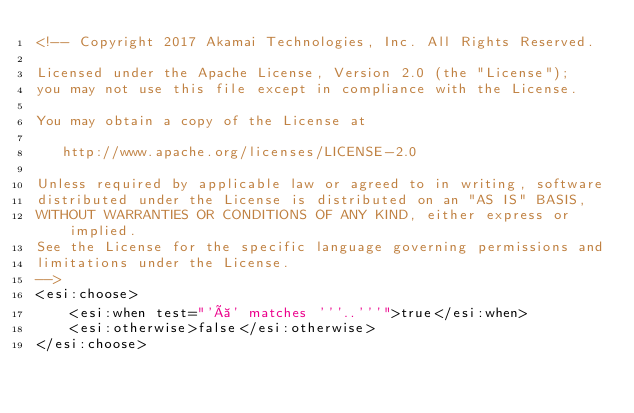<code> <loc_0><loc_0><loc_500><loc_500><_HTML_><!-- Copyright 2017 Akamai Technologies, Inc. All Rights Reserved.

Licensed under the Apache License, Version 2.0 (the "License");
you may not use this file except in compliance with the License.

You may obtain a copy of the License at

   http://www.apache.org/licenses/LICENSE-2.0

Unless required by applicable law or agreed to in writing, software
distributed under the License is distributed on an "AS IS" BASIS,
WITHOUT WARRANTIES OR CONDITIONS OF ANY KIND, either express or implied.
See the License for the specific language governing permissions and
limitations under the License.
-->
<esi:choose>
    <esi:when test="'à' matches '''..'''">true</esi:when>
    <esi:otherwise>false</esi:otherwise>
</esi:choose></code> 